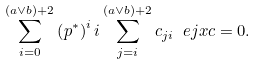Convert formula to latex. <formula><loc_0><loc_0><loc_500><loc_500>\sum _ { i = 0 } ^ { ( a \vee b ) + 2 } \left ( p ^ { \ast } \right ) ^ { i } i \sum _ { j = i } ^ { ( a \vee b ) + 2 } c _ { j i } \ e j x c = 0 .</formula> 